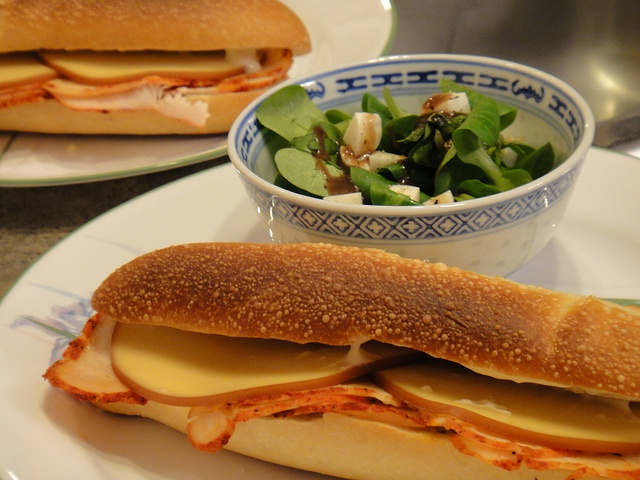Describe the objects in this image and their specific colors. I can see dining table in orange, brown, tan, and maroon tones, sandwich in orange, red, and tan tones, apple in orange, brown, and maroon tones, and dining table in orange, black, olive, and gray tones in this image. 